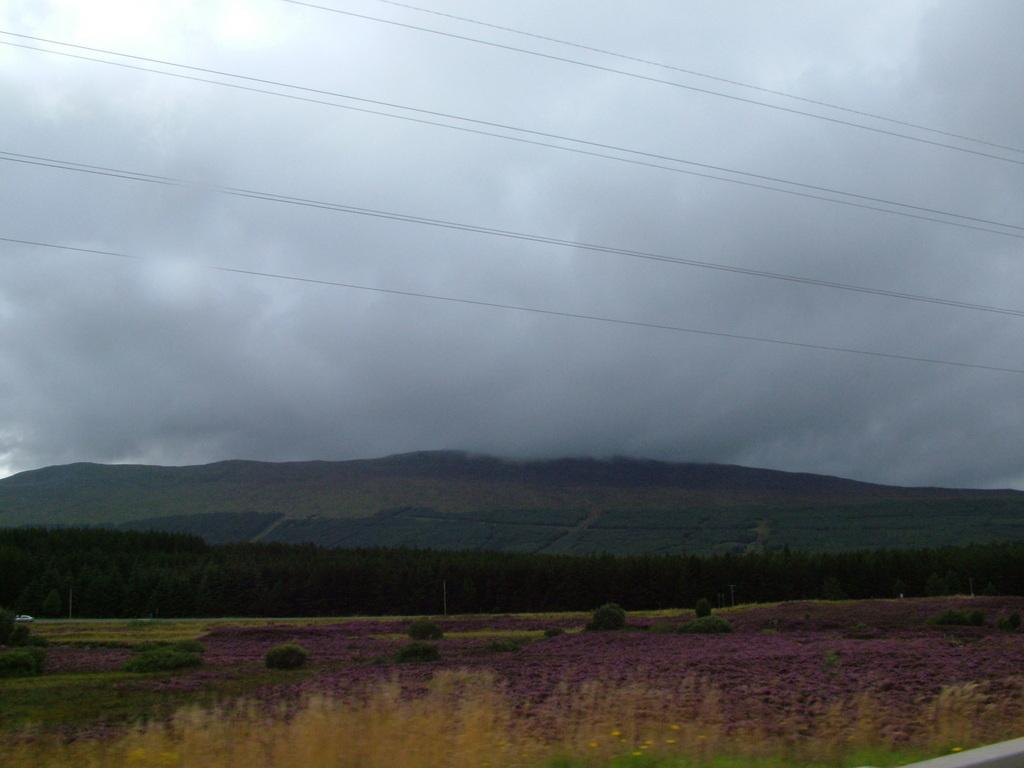What type of living organisms can be seen in the image? Plants and trees are visible in the image. What other objects can be seen in the image? There are wires in the image. What can be seen in the background of the image? Trees, mountains, and the sky are visible in the background of the image. What is the condition of the sky in the image? The sky is cloudy in the image. Can you tell me where the cobweb is located in the image? There is no cobweb present in the image. What type of lunch is being served in the image? There is no lunch depicted in the image. 